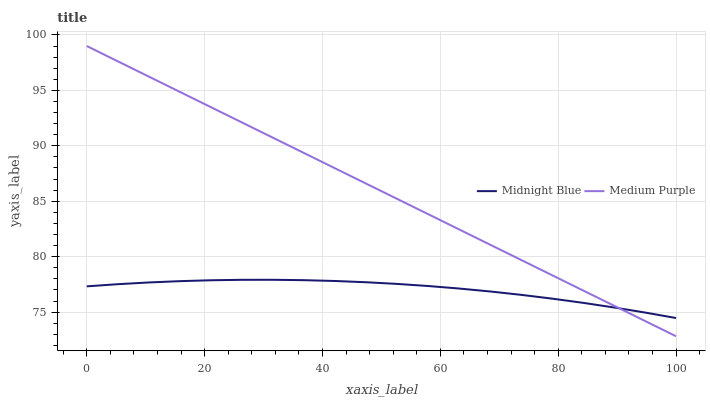Does Midnight Blue have the minimum area under the curve?
Answer yes or no. Yes. Does Medium Purple have the maximum area under the curve?
Answer yes or no. Yes. Does Midnight Blue have the maximum area under the curve?
Answer yes or no. No. Is Medium Purple the smoothest?
Answer yes or no. Yes. Is Midnight Blue the roughest?
Answer yes or no. Yes. Is Midnight Blue the smoothest?
Answer yes or no. No. Does Medium Purple have the lowest value?
Answer yes or no. Yes. Does Midnight Blue have the lowest value?
Answer yes or no. No. Does Medium Purple have the highest value?
Answer yes or no. Yes. Does Midnight Blue have the highest value?
Answer yes or no. No. Does Medium Purple intersect Midnight Blue?
Answer yes or no. Yes. Is Medium Purple less than Midnight Blue?
Answer yes or no. No. Is Medium Purple greater than Midnight Blue?
Answer yes or no. No. 